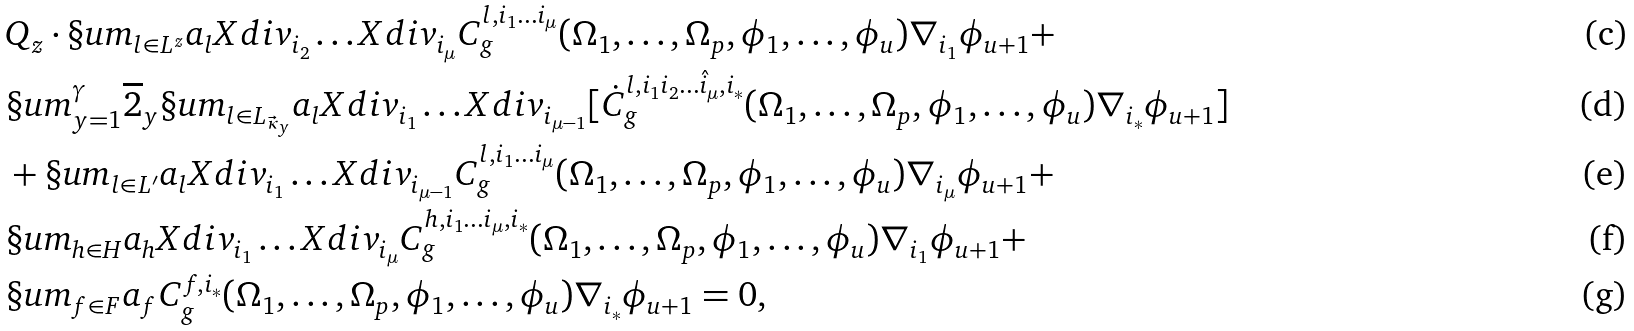Convert formula to latex. <formula><loc_0><loc_0><loc_500><loc_500>& Q _ { z } \cdot \S u m _ { l \in L ^ { z } } a _ { l } X d i v _ { i _ { 2 } } \dots X d i v _ { i _ { \mu } } C ^ { l , i _ { 1 } \dots i _ { \mu } } _ { g } ( \Omega _ { 1 } , \dots , \Omega _ { p } , \phi _ { 1 } , \dots , \phi _ { u } ) \nabla _ { i _ { 1 } } \phi _ { u + 1 } + \\ & \S u m _ { y = 1 } ^ { \gamma } \overline { 2 } _ { y } \S u m _ { l \in L _ { \vec { \kappa } _ { y } } } a _ { l } X d i v _ { i _ { 1 } } \dots X d i v _ { i _ { \mu - 1 } } [ \dot { C } ^ { l , i _ { 1 } i _ { 2 } \dots \hat { i } _ { \mu } , i _ { * } } _ { g } ( \Omega _ { 1 } , \dots , \Omega _ { p } , \phi _ { 1 } , \dots , \phi _ { u } ) \nabla _ { i _ { * } } \phi _ { u + 1 } ] \\ & + \S u m _ { l \in L ^ { \prime } } a _ { l } X d i v _ { i _ { 1 } } \dots X d i v _ { i _ { \mu - 1 } } C ^ { l , i _ { 1 } \dots i _ { \mu } } _ { g } ( \Omega _ { 1 } , \dots , \Omega _ { p } , \phi _ { 1 } , \dots , \phi _ { u } ) \nabla _ { i _ { \mu } } \phi _ { u + 1 } + \\ & \S u m _ { h \in H } a _ { h } X d i v _ { i _ { 1 } } \dots X d i v _ { i _ { \mu } } C ^ { h , i _ { 1 } \dots i _ { \mu } , i _ { * } } _ { g } ( \Omega _ { 1 } , \dots , \Omega _ { p } , \phi _ { 1 } , \dots , \phi _ { u } ) \nabla _ { i _ { 1 } } \phi _ { u + 1 } + \\ & \S u m _ { f \in F } a _ { f } C ^ { f , i _ { * } } _ { g } ( \Omega _ { 1 } , \dots , \Omega _ { p } , \phi _ { 1 } , \dots , \phi _ { u } ) \nabla _ { i _ { * } } \phi _ { u + 1 } = 0 ,</formula> 